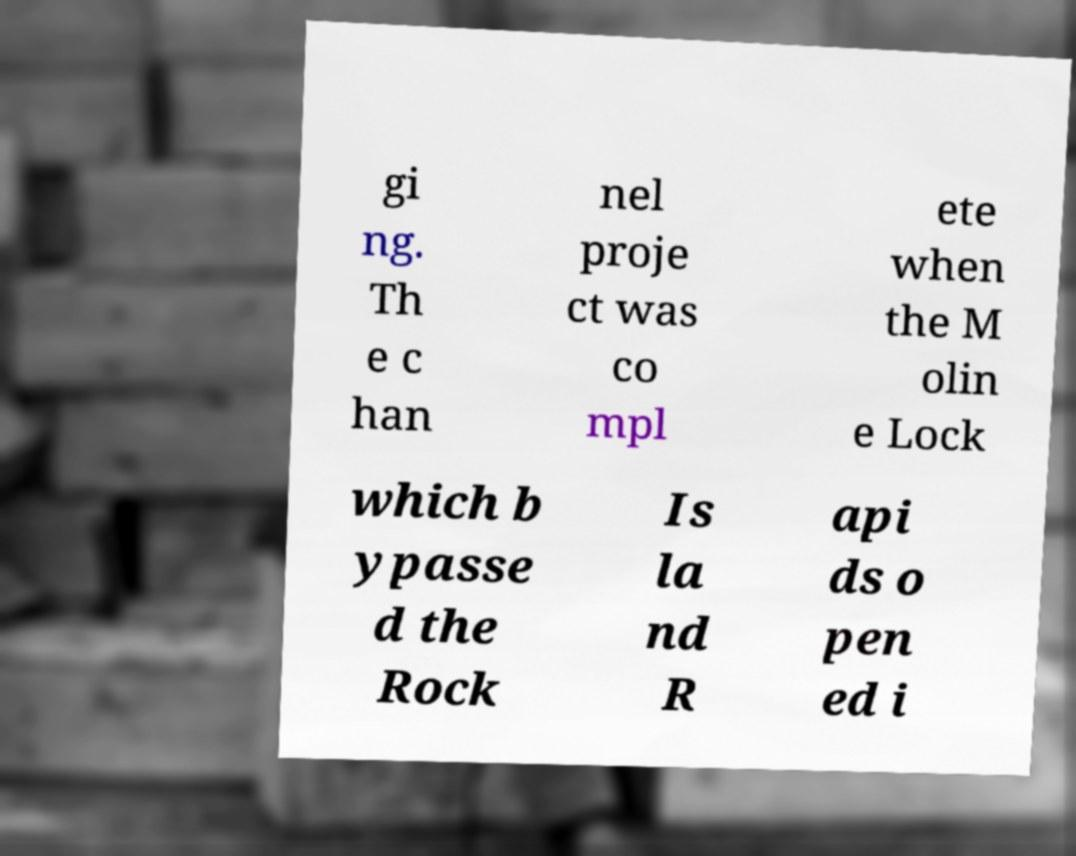Please identify and transcribe the text found in this image. gi ng. Th e c han nel proje ct was co mpl ete when the M olin e Lock which b ypasse d the Rock Is la nd R api ds o pen ed i 